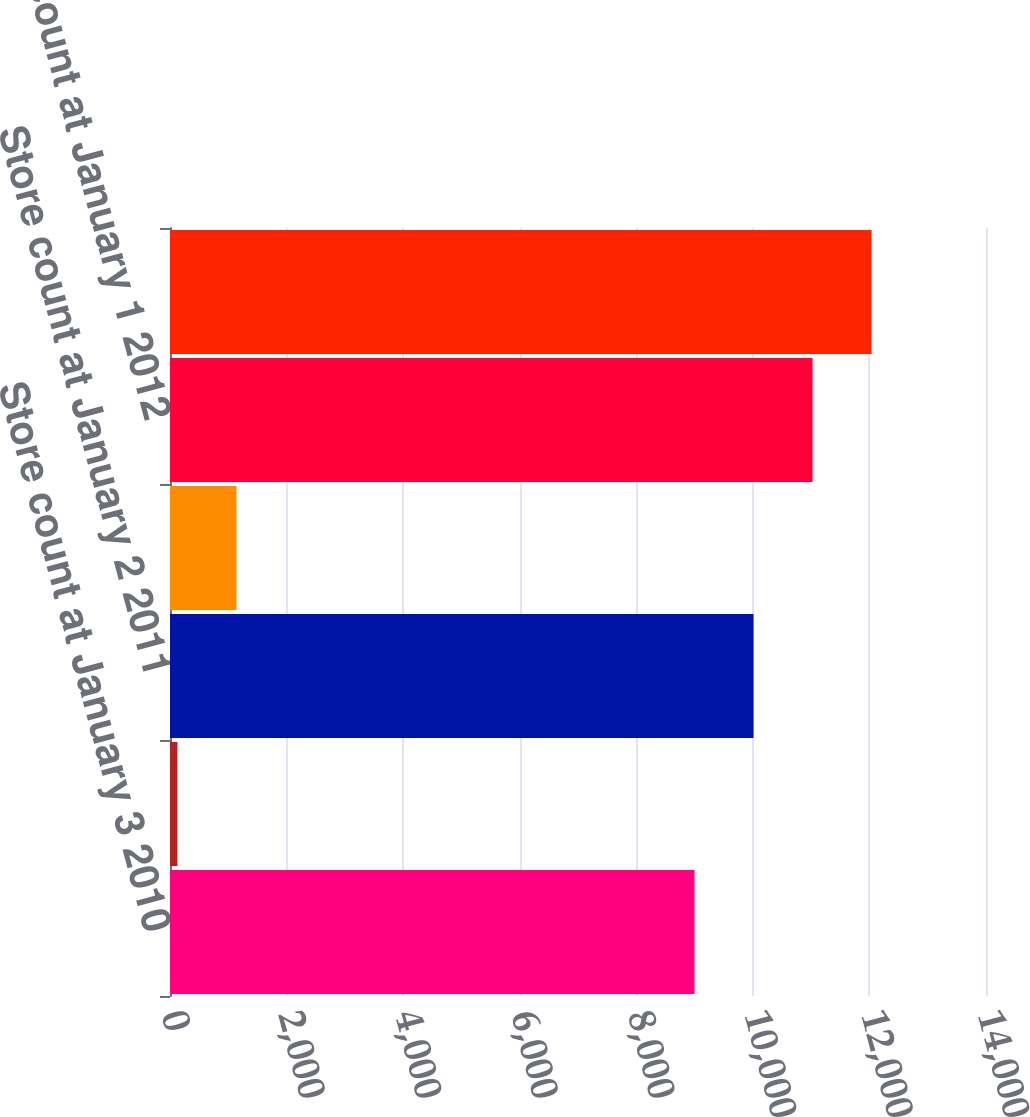<chart> <loc_0><loc_0><loc_500><loc_500><bar_chart><fcel>Store count at January 3 2010<fcel>Closings<fcel>Store count at January 2 2011<fcel>Openings<fcel>Store count at January 1 2012<fcel>Store count at December 30<nl><fcel>8999<fcel>128<fcel>10011.7<fcel>1140.7<fcel>11024.4<fcel>12037.1<nl></chart> 